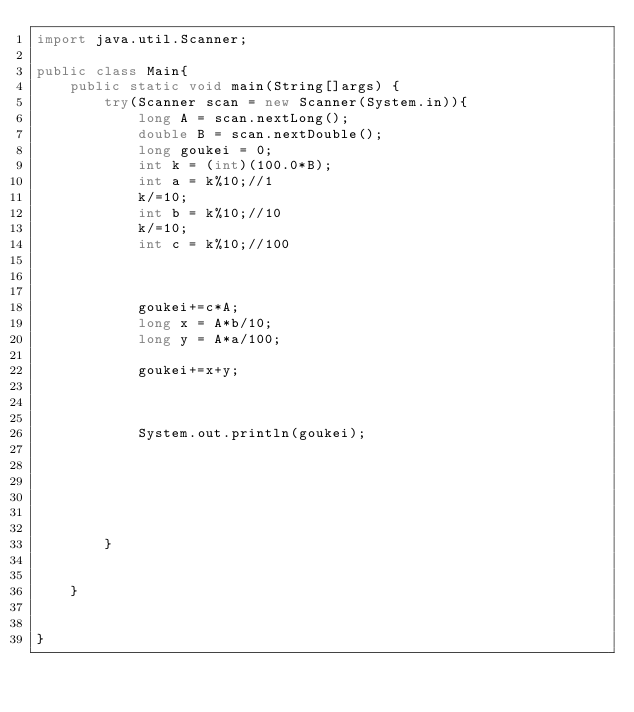<code> <loc_0><loc_0><loc_500><loc_500><_Java_>import java.util.Scanner;

public class Main{
	public static void main(String[]args) {
		try(Scanner scan = new Scanner(System.in)){
			long A = scan.nextLong();
			double B = scan.nextDouble();
			long goukei = 0;
			int k = (int)(100.0*B);
			int a = k%10;//1
			k/=10;
			int b = k%10;//10
			k/=10;
			int c = k%10;//100
			
			
			
			goukei+=c*A;
			long x = A*b/10;
			long y = A*a/100;
			
			goukei+=x+y;
			
			
	
			System.out.println(goukei);
			
			
			
			
			
			
		}
		
		
	}
		

}
</code> 